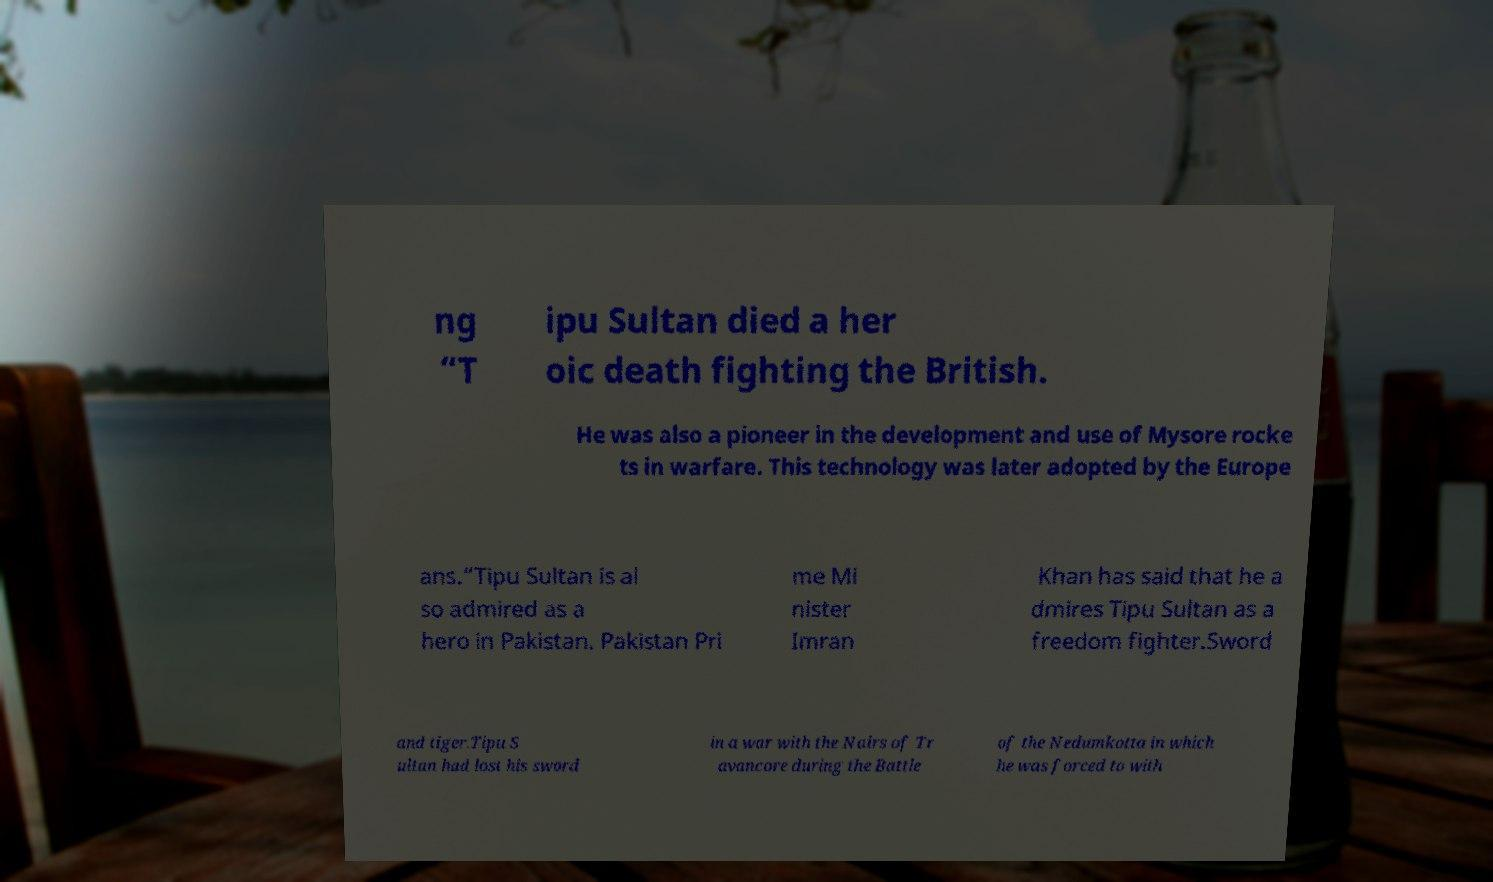I need the written content from this picture converted into text. Can you do that? ng “T ipu Sultan died a her oic death fighting the British. He was also a pioneer in the development and use of Mysore rocke ts in warfare. This technology was later adopted by the Europe ans.“Tipu Sultan is al so admired as a hero in Pakistan. Pakistan Pri me Mi nister Imran Khan has said that he a dmires Tipu Sultan as a freedom fighter.Sword and tiger.Tipu S ultan had lost his sword in a war with the Nairs of Tr avancore during the Battle of the Nedumkotta in which he was forced to with 